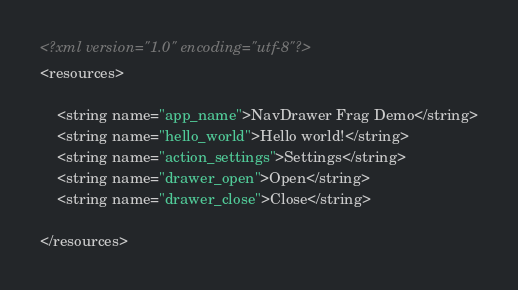Convert code to text. <code><loc_0><loc_0><loc_500><loc_500><_XML_><?xml version="1.0" encoding="utf-8"?>
<resources>

    <string name="app_name">NavDrawer Frag Demo</string>
    <string name="hello_world">Hello world!</string>
    <string name="action_settings">Settings</string>
    <string name="drawer_open">Open</string>
    <string name="drawer_close">Close</string>

</resources>
</code> 